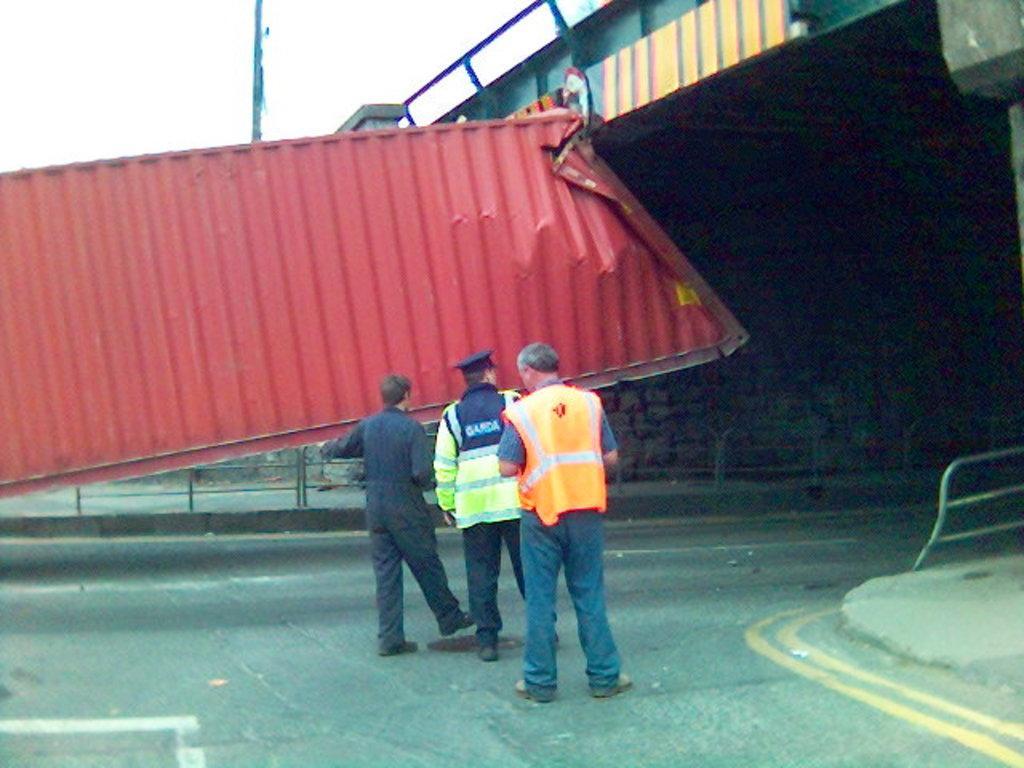In one or two sentences, can you explain what this image depicts? In the center of the image we can see three people standing. On the right there is a bridge and we can see a metal sheet. At the bottom we can see a road. In the background there is fence and sky. 